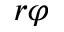<formula> <loc_0><loc_0><loc_500><loc_500>r \varphi</formula> 